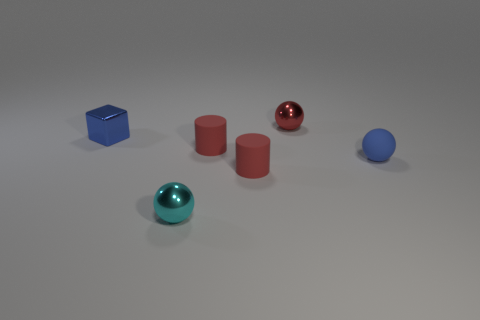Add 3 large yellow rubber spheres. How many objects exist? 9 Subtract all cylinders. How many objects are left? 4 Add 4 big things. How many big things exist? 4 Subtract 0 gray balls. How many objects are left? 6 Subtract all tiny rubber cubes. Subtract all matte cylinders. How many objects are left? 4 Add 5 blocks. How many blocks are left? 6 